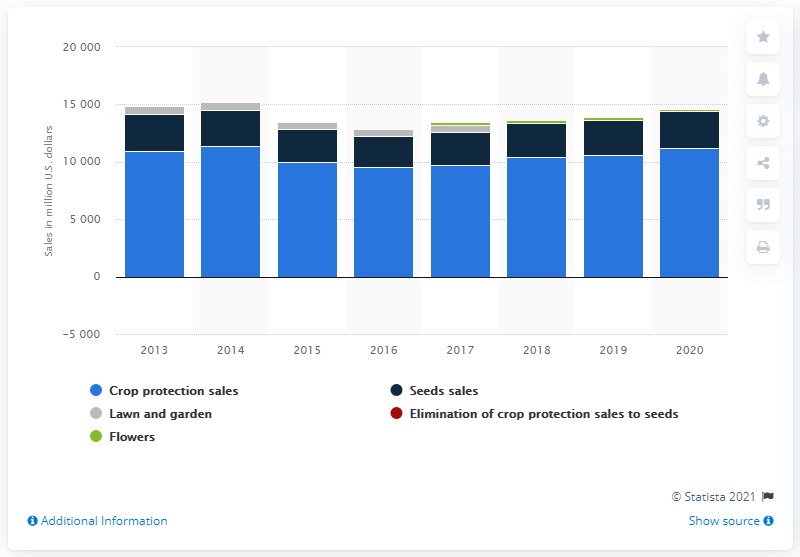Point out several critical features in this image. Syngenta's crop protection sales in 2014 were approximately 11,381. In 2019, Syngenta's crop protection sales were 11,208. 